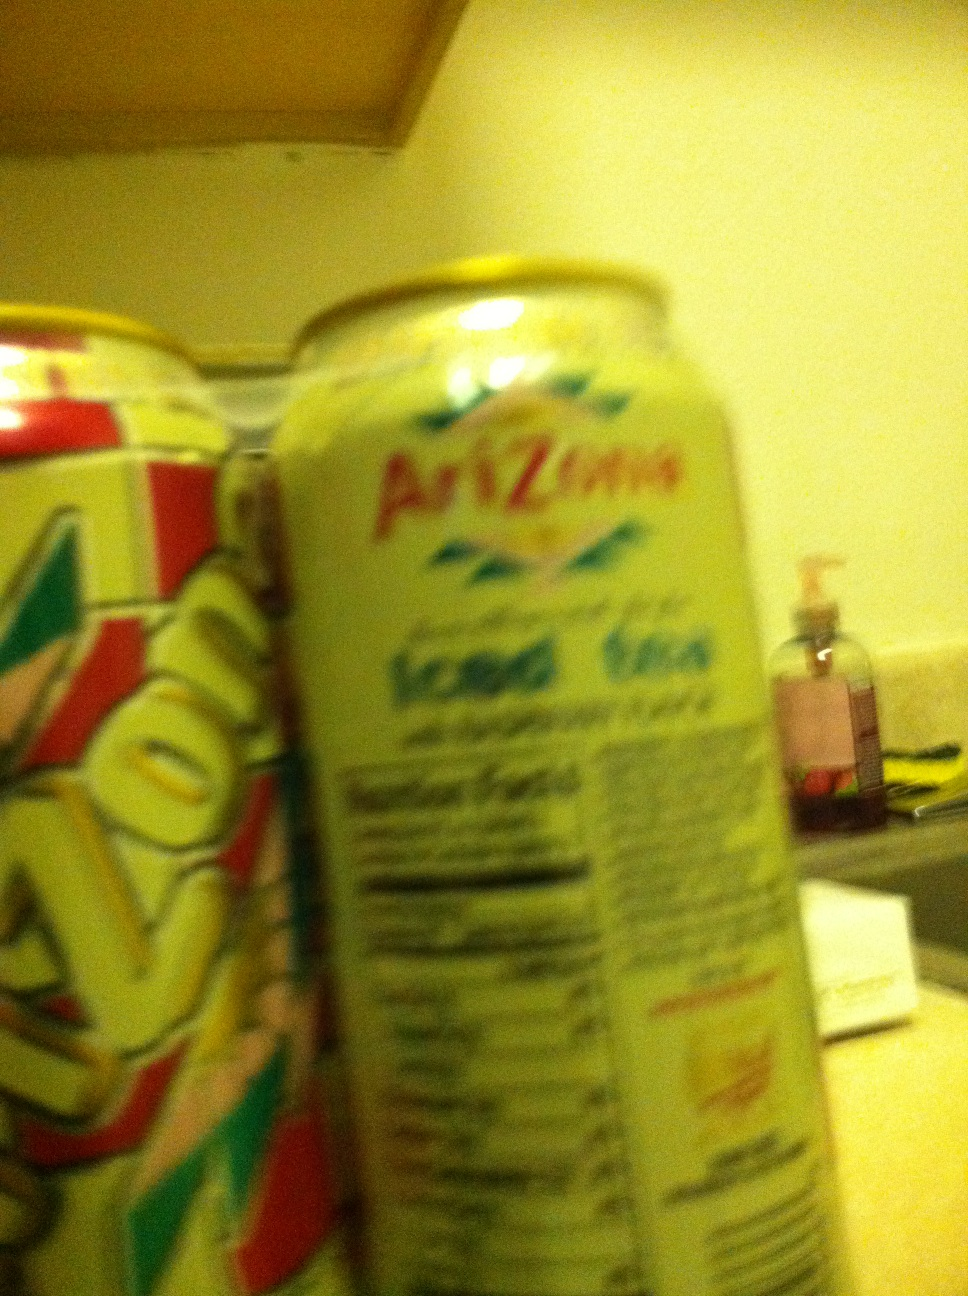Could you explain the health benefits mentioned on this Arizona tea can? The 'Green Tea with Ginseng and Honey' offers potential health benefits primarily through its key ingredients. Green tea is rich in antioxidants, particularly EGCG, which may reduce inflammation and support heart health. Ginseng is often used for its supposed ability to enhance mental clarity and energy. Honey, being a natural sweetener, provides a healthier alternative to sugar, potentially aiding in digestion and providing antioxidants as well. 